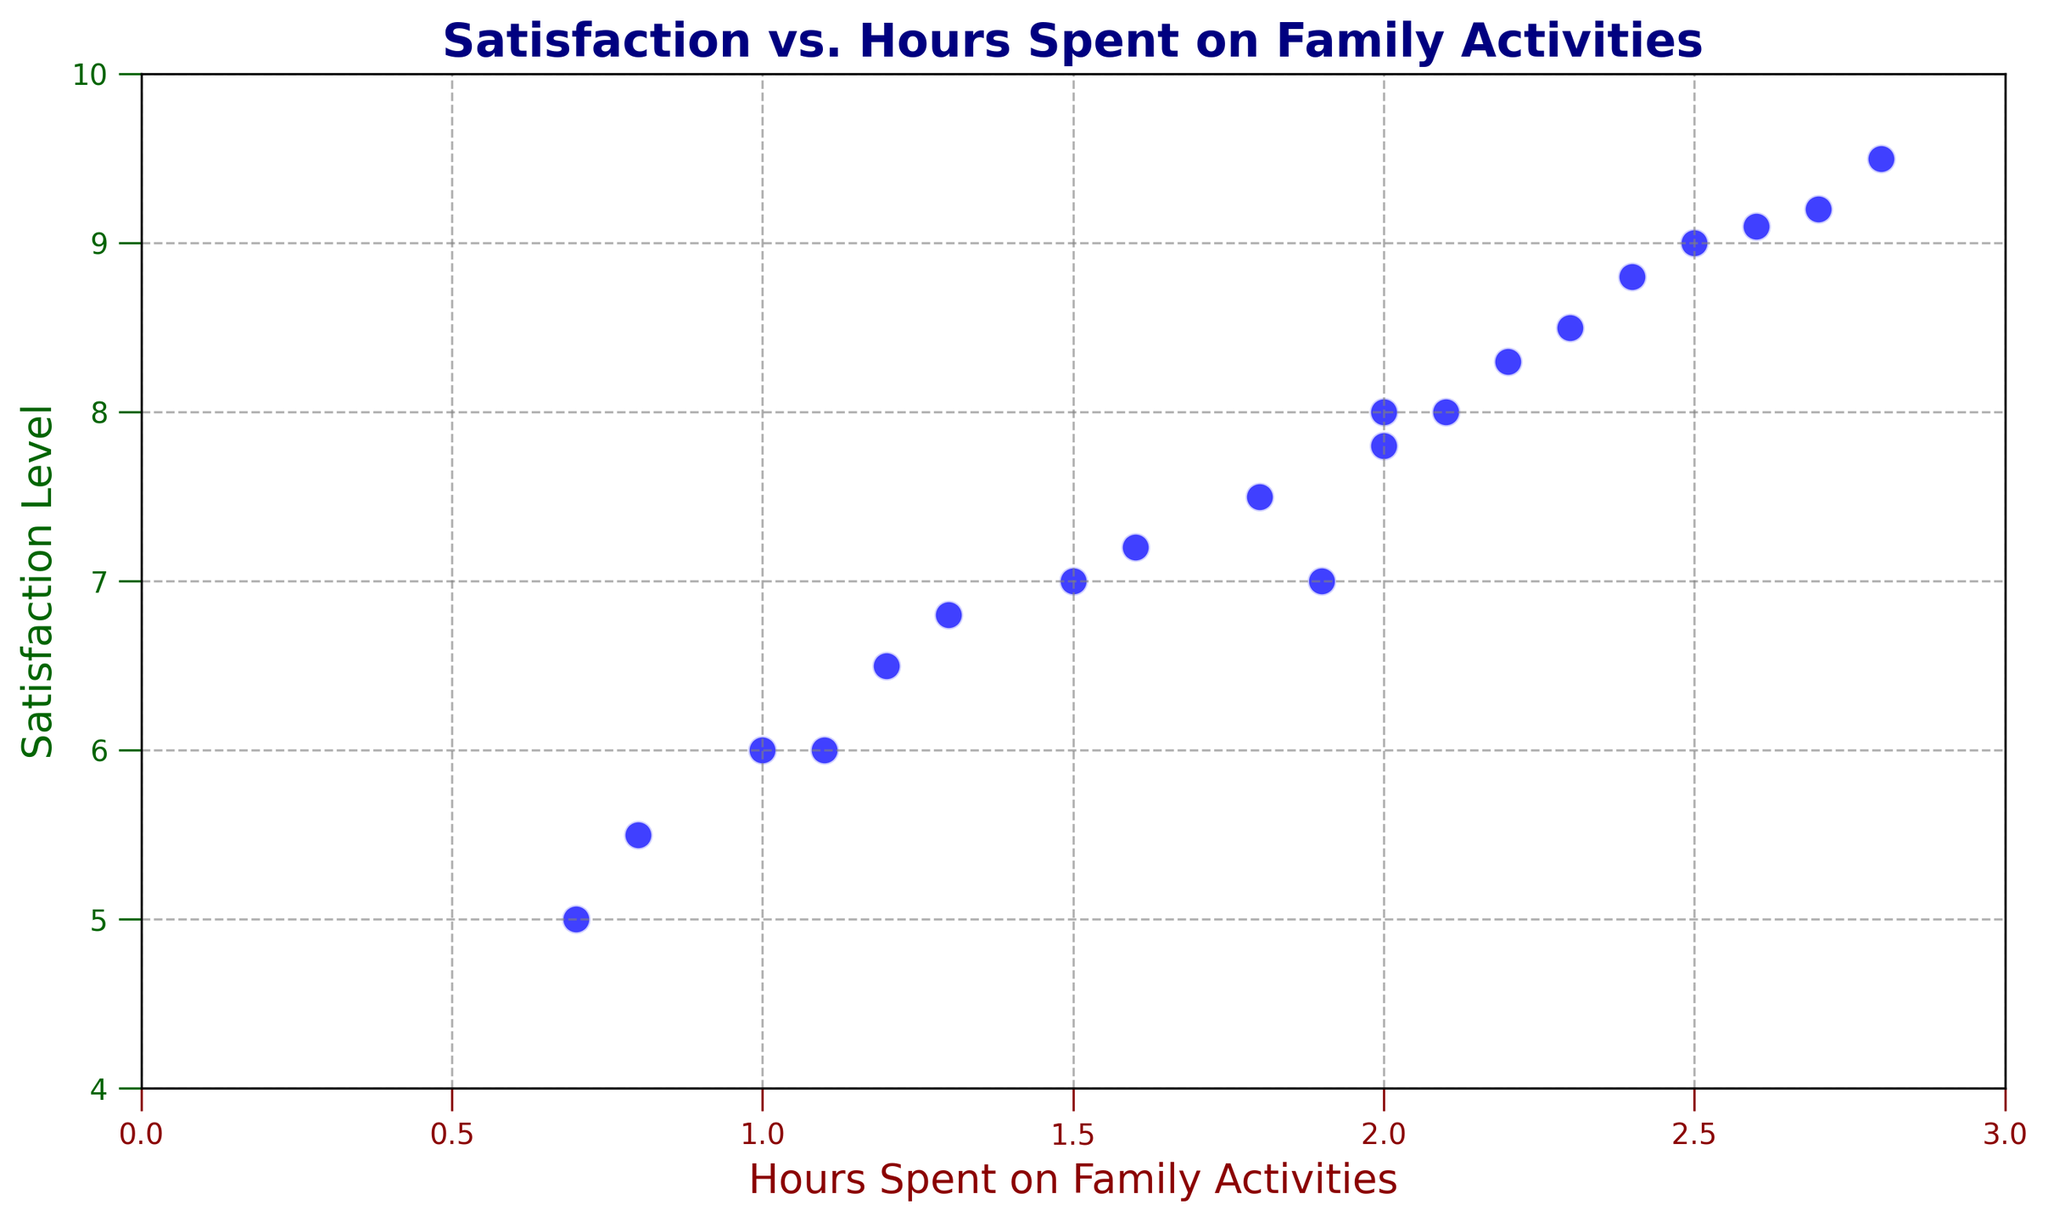What is the highest satisfaction level recorded in the plot? Identify the point with the highest y-coordinate which represents the satisfaction level. The highest point on the y-axis is at 9.5.
Answer: 9.5 What is the average number of hours spent on family activities? Sum up all the hours spent on family activities: (2 + 1.5 + 2.5 + 1 + 1.8 + 2.3 + 0.7 + 2.7 + 1.2 + 2.1 + 1.6 + 1.3 + 2.4 + 2.8 + 1.9 + 1.1 + 2 + 2.2 + 2.6 + 0.8). Count the number of data points, which is 20. The average is the total hours divided by the number of data points: 38.5 / 20.
Answer: 1.925 Which data point represents a family with a satisfaction level of 8 and how many hours did they spend on family activities? Locate the point where the y-coordinate is 8. The corresponding x-coordinate is 2. Therefore, the number of hours spent on family activities is 2.0.
Answer: 2.0 Does spending more hours on family activities tend to result in higher satisfaction levels? Observe the general trend of the scatter plot. The satisfaction levels tend to increase as the hours spent on family activities increase.
Answer: Yes Which family spent the least amount of hours on family activities, and what is their satisfaction level? Identify the point with the lowest x-coordinate, which represents the hours spent on family activities. The lowest value is 0.7 hours. The corresponding satisfaction level for this point is 5.
Answer: 5 Compare the satisfaction levels for families who spent exactly 2 hours and 2.5 hours on family activities. Which is higher? Locate the points where the x-coordinates are 2 and 2.5 hours. The corresponding satisfaction levels are 7.8 (for 2 hours) and 9 (for 2.5 hours). The satisfaction level is higher for the family who spent 2.5 hours.
Answer: 2.5 hours What is the median satisfaction level? Sort the satisfaction levels: 5, 5.5, 6, 6, 6.5, 6.8, 7, 7, 7.2, 7.5, 7.8, 8, 8, 8.3, 8.5, 8.8, 9, 9.1, 9.2, 9.5. Since there are 20 data points, the median is the average of the 10th and 11th values: (7.5 + 7.8) / 2.
Answer: 7.65 What visual attribute indicates the scatter plot may contain overlapping points? Some points appear to be very close to each other or partially overlapping, making it hard to distinguish individual markers. This is noticeable in denser areas near x-coordinates like 2.
Answer: Overlapping points 